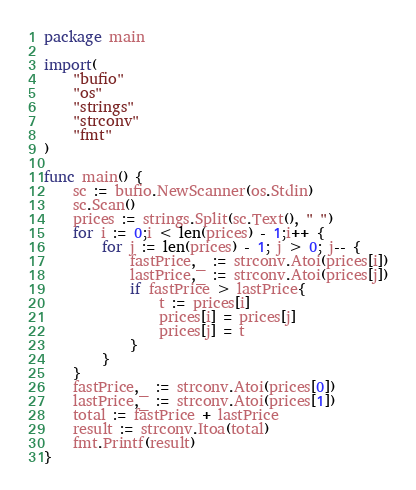Convert code to text. <code><loc_0><loc_0><loc_500><loc_500><_Go_>package main

import(
	"bufio"
	"os"
	"strings"
	"strconv"
	"fmt"
)

func main() {
	sc := bufio.NewScanner(os.Stdin)
	sc.Scan()
	prices := strings.Split(sc.Text(), " ")
 	for i := 0;i < len(prices) - 1;i++ {
		for j := len(prices) - 1; j > 0; j-- {
			fastPrice,_ := strconv.Atoi(prices[i])
			lastPrice,_ := strconv.Atoi(prices[j])
			if fastPrice > lastPrice{
				t := prices[i]
				prices[i] = prices[j]
				prices[j] = t
			}
		}
	}
	fastPrice,_ := strconv.Atoi(prices[0])
	lastPrice,_ := strconv.Atoi(prices[1])
	total := fastPrice + lastPrice
	result := strconv.Itoa(total)
	fmt.Printf(result)
}</code> 